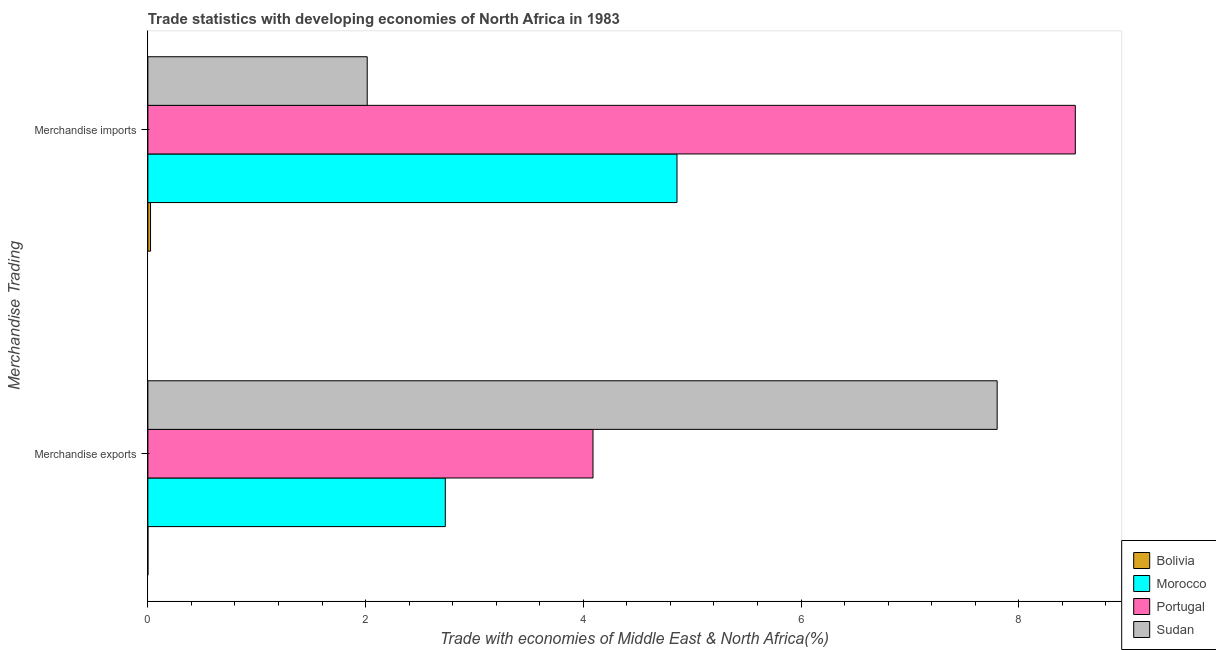How many groups of bars are there?
Give a very brief answer. 2. Are the number of bars on each tick of the Y-axis equal?
Your answer should be very brief. Yes. How many bars are there on the 2nd tick from the top?
Make the answer very short. 4. What is the label of the 1st group of bars from the top?
Your answer should be compact. Merchandise imports. What is the merchandise exports in Bolivia?
Provide a short and direct response. 0. Across all countries, what is the maximum merchandise exports?
Provide a short and direct response. 7.8. Across all countries, what is the minimum merchandise imports?
Provide a succinct answer. 0.02. In which country was the merchandise exports maximum?
Give a very brief answer. Sudan. In which country was the merchandise imports minimum?
Offer a very short reply. Bolivia. What is the total merchandise exports in the graph?
Offer a terse response. 14.62. What is the difference between the merchandise exports in Morocco and that in Portugal?
Your response must be concise. -1.36. What is the difference between the merchandise exports in Portugal and the merchandise imports in Morocco?
Give a very brief answer. -0.77. What is the average merchandise exports per country?
Give a very brief answer. 3.66. What is the difference between the merchandise exports and merchandise imports in Portugal?
Your answer should be very brief. -4.43. What is the ratio of the merchandise imports in Portugal to that in Morocco?
Offer a terse response. 1.75. Is the merchandise exports in Portugal less than that in Morocco?
Make the answer very short. No. What does the 1st bar from the top in Merchandise imports represents?
Your answer should be compact. Sudan. What does the 4th bar from the bottom in Merchandise exports represents?
Your answer should be very brief. Sudan. How many bars are there?
Give a very brief answer. 8. How many countries are there in the graph?
Give a very brief answer. 4. What is the difference between two consecutive major ticks on the X-axis?
Offer a terse response. 2. Are the values on the major ticks of X-axis written in scientific E-notation?
Provide a short and direct response. No. Does the graph contain any zero values?
Provide a short and direct response. No. Where does the legend appear in the graph?
Your answer should be very brief. Bottom right. What is the title of the graph?
Give a very brief answer. Trade statistics with developing economies of North Africa in 1983. Does "World" appear as one of the legend labels in the graph?
Your answer should be compact. No. What is the label or title of the X-axis?
Provide a short and direct response. Trade with economies of Middle East & North Africa(%). What is the label or title of the Y-axis?
Ensure brevity in your answer.  Merchandise Trading. What is the Trade with economies of Middle East & North Africa(%) in Bolivia in Merchandise exports?
Your answer should be compact. 0. What is the Trade with economies of Middle East & North Africa(%) of Morocco in Merchandise exports?
Ensure brevity in your answer.  2.73. What is the Trade with economies of Middle East & North Africa(%) of Portugal in Merchandise exports?
Give a very brief answer. 4.09. What is the Trade with economies of Middle East & North Africa(%) of Sudan in Merchandise exports?
Your answer should be compact. 7.8. What is the Trade with economies of Middle East & North Africa(%) of Bolivia in Merchandise imports?
Your response must be concise. 0.02. What is the Trade with economies of Middle East & North Africa(%) of Morocco in Merchandise imports?
Your response must be concise. 4.86. What is the Trade with economies of Middle East & North Africa(%) in Portugal in Merchandise imports?
Your answer should be compact. 8.52. What is the Trade with economies of Middle East & North Africa(%) in Sudan in Merchandise imports?
Your response must be concise. 2.01. Across all Merchandise Trading, what is the maximum Trade with economies of Middle East & North Africa(%) in Bolivia?
Make the answer very short. 0.02. Across all Merchandise Trading, what is the maximum Trade with economies of Middle East & North Africa(%) in Morocco?
Your answer should be very brief. 4.86. Across all Merchandise Trading, what is the maximum Trade with economies of Middle East & North Africa(%) in Portugal?
Keep it short and to the point. 8.52. Across all Merchandise Trading, what is the maximum Trade with economies of Middle East & North Africa(%) in Sudan?
Keep it short and to the point. 7.8. Across all Merchandise Trading, what is the minimum Trade with economies of Middle East & North Africa(%) in Bolivia?
Provide a succinct answer. 0. Across all Merchandise Trading, what is the minimum Trade with economies of Middle East & North Africa(%) in Morocco?
Your response must be concise. 2.73. Across all Merchandise Trading, what is the minimum Trade with economies of Middle East & North Africa(%) of Portugal?
Make the answer very short. 4.09. Across all Merchandise Trading, what is the minimum Trade with economies of Middle East & North Africa(%) in Sudan?
Provide a succinct answer. 2.01. What is the total Trade with economies of Middle East & North Africa(%) in Bolivia in the graph?
Offer a very short reply. 0.02. What is the total Trade with economies of Middle East & North Africa(%) in Morocco in the graph?
Your answer should be compact. 7.59. What is the total Trade with economies of Middle East & North Africa(%) of Portugal in the graph?
Make the answer very short. 12.61. What is the total Trade with economies of Middle East & North Africa(%) of Sudan in the graph?
Your answer should be compact. 9.82. What is the difference between the Trade with economies of Middle East & North Africa(%) of Bolivia in Merchandise exports and that in Merchandise imports?
Provide a short and direct response. -0.02. What is the difference between the Trade with economies of Middle East & North Africa(%) in Morocco in Merchandise exports and that in Merchandise imports?
Give a very brief answer. -2.13. What is the difference between the Trade with economies of Middle East & North Africa(%) in Portugal in Merchandise exports and that in Merchandise imports?
Ensure brevity in your answer.  -4.43. What is the difference between the Trade with economies of Middle East & North Africa(%) of Sudan in Merchandise exports and that in Merchandise imports?
Offer a terse response. 5.79. What is the difference between the Trade with economies of Middle East & North Africa(%) of Bolivia in Merchandise exports and the Trade with economies of Middle East & North Africa(%) of Morocco in Merchandise imports?
Provide a short and direct response. -4.86. What is the difference between the Trade with economies of Middle East & North Africa(%) in Bolivia in Merchandise exports and the Trade with economies of Middle East & North Africa(%) in Portugal in Merchandise imports?
Keep it short and to the point. -8.52. What is the difference between the Trade with economies of Middle East & North Africa(%) in Bolivia in Merchandise exports and the Trade with economies of Middle East & North Africa(%) in Sudan in Merchandise imports?
Provide a short and direct response. -2.01. What is the difference between the Trade with economies of Middle East & North Africa(%) in Morocco in Merchandise exports and the Trade with economies of Middle East & North Africa(%) in Portugal in Merchandise imports?
Provide a succinct answer. -5.79. What is the difference between the Trade with economies of Middle East & North Africa(%) of Morocco in Merchandise exports and the Trade with economies of Middle East & North Africa(%) of Sudan in Merchandise imports?
Your answer should be very brief. 0.72. What is the difference between the Trade with economies of Middle East & North Africa(%) in Portugal in Merchandise exports and the Trade with economies of Middle East & North Africa(%) in Sudan in Merchandise imports?
Your answer should be compact. 2.07. What is the average Trade with economies of Middle East & North Africa(%) of Bolivia per Merchandise Trading?
Keep it short and to the point. 0.01. What is the average Trade with economies of Middle East & North Africa(%) of Morocco per Merchandise Trading?
Offer a very short reply. 3.8. What is the average Trade with economies of Middle East & North Africa(%) in Portugal per Merchandise Trading?
Give a very brief answer. 6.3. What is the average Trade with economies of Middle East & North Africa(%) in Sudan per Merchandise Trading?
Your answer should be very brief. 4.91. What is the difference between the Trade with economies of Middle East & North Africa(%) in Bolivia and Trade with economies of Middle East & North Africa(%) in Morocco in Merchandise exports?
Ensure brevity in your answer.  -2.73. What is the difference between the Trade with economies of Middle East & North Africa(%) in Bolivia and Trade with economies of Middle East & North Africa(%) in Portugal in Merchandise exports?
Keep it short and to the point. -4.09. What is the difference between the Trade with economies of Middle East & North Africa(%) of Bolivia and Trade with economies of Middle East & North Africa(%) of Sudan in Merchandise exports?
Make the answer very short. -7.8. What is the difference between the Trade with economies of Middle East & North Africa(%) in Morocco and Trade with economies of Middle East & North Africa(%) in Portugal in Merchandise exports?
Keep it short and to the point. -1.36. What is the difference between the Trade with economies of Middle East & North Africa(%) in Morocco and Trade with economies of Middle East & North Africa(%) in Sudan in Merchandise exports?
Offer a terse response. -5.07. What is the difference between the Trade with economies of Middle East & North Africa(%) in Portugal and Trade with economies of Middle East & North Africa(%) in Sudan in Merchandise exports?
Provide a short and direct response. -3.71. What is the difference between the Trade with economies of Middle East & North Africa(%) in Bolivia and Trade with economies of Middle East & North Africa(%) in Morocco in Merchandise imports?
Make the answer very short. -4.84. What is the difference between the Trade with economies of Middle East & North Africa(%) in Bolivia and Trade with economies of Middle East & North Africa(%) in Portugal in Merchandise imports?
Provide a succinct answer. -8.5. What is the difference between the Trade with economies of Middle East & North Africa(%) in Bolivia and Trade with economies of Middle East & North Africa(%) in Sudan in Merchandise imports?
Ensure brevity in your answer.  -1.99. What is the difference between the Trade with economies of Middle East & North Africa(%) in Morocco and Trade with economies of Middle East & North Africa(%) in Portugal in Merchandise imports?
Provide a short and direct response. -3.66. What is the difference between the Trade with economies of Middle East & North Africa(%) in Morocco and Trade with economies of Middle East & North Africa(%) in Sudan in Merchandise imports?
Provide a short and direct response. 2.85. What is the difference between the Trade with economies of Middle East & North Africa(%) in Portugal and Trade with economies of Middle East & North Africa(%) in Sudan in Merchandise imports?
Offer a terse response. 6.5. What is the ratio of the Trade with economies of Middle East & North Africa(%) of Bolivia in Merchandise exports to that in Merchandise imports?
Keep it short and to the point. 0.01. What is the ratio of the Trade with economies of Middle East & North Africa(%) in Morocco in Merchandise exports to that in Merchandise imports?
Offer a terse response. 0.56. What is the ratio of the Trade with economies of Middle East & North Africa(%) in Portugal in Merchandise exports to that in Merchandise imports?
Give a very brief answer. 0.48. What is the ratio of the Trade with economies of Middle East & North Africa(%) of Sudan in Merchandise exports to that in Merchandise imports?
Provide a succinct answer. 3.87. What is the difference between the highest and the second highest Trade with economies of Middle East & North Africa(%) in Bolivia?
Give a very brief answer. 0.02. What is the difference between the highest and the second highest Trade with economies of Middle East & North Africa(%) in Morocco?
Give a very brief answer. 2.13. What is the difference between the highest and the second highest Trade with economies of Middle East & North Africa(%) in Portugal?
Your response must be concise. 4.43. What is the difference between the highest and the second highest Trade with economies of Middle East & North Africa(%) in Sudan?
Your answer should be compact. 5.79. What is the difference between the highest and the lowest Trade with economies of Middle East & North Africa(%) in Bolivia?
Provide a succinct answer. 0.02. What is the difference between the highest and the lowest Trade with economies of Middle East & North Africa(%) of Morocco?
Provide a short and direct response. 2.13. What is the difference between the highest and the lowest Trade with economies of Middle East & North Africa(%) in Portugal?
Your answer should be very brief. 4.43. What is the difference between the highest and the lowest Trade with economies of Middle East & North Africa(%) of Sudan?
Make the answer very short. 5.79. 